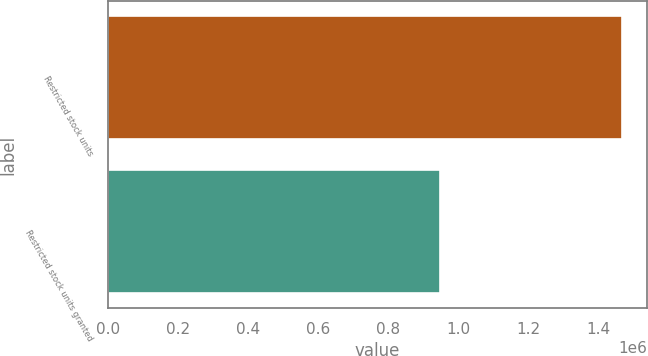<chart> <loc_0><loc_0><loc_500><loc_500><bar_chart><fcel>Restricted stock units<fcel>Restricted stock units granted<nl><fcel>1.46634e+06<fcel>948442<nl></chart> 